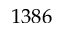<formula> <loc_0><loc_0><loc_500><loc_500>1 3 8 6</formula> 